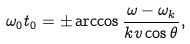<formula> <loc_0><loc_0><loc_500><loc_500>\omega _ { 0 } t _ { 0 } = \pm \arccos \frac { \omega - \omega _ { k } } { k v \cos \theta } ,</formula> 